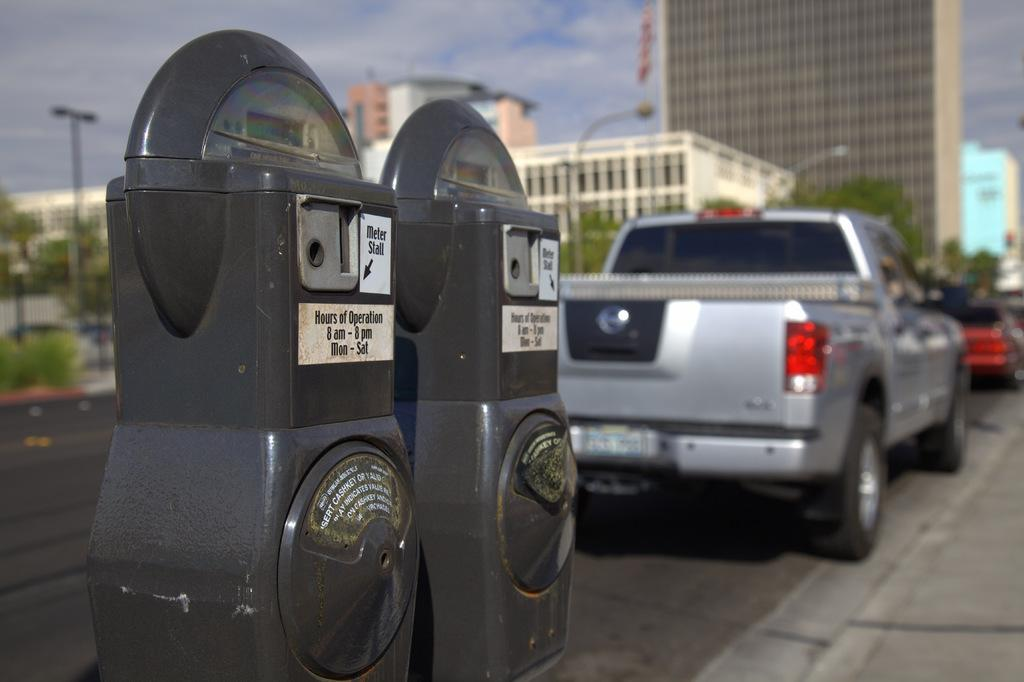<image>
Share a concise interpretation of the image provided. Two metres with the words Hours of Operation on them. 